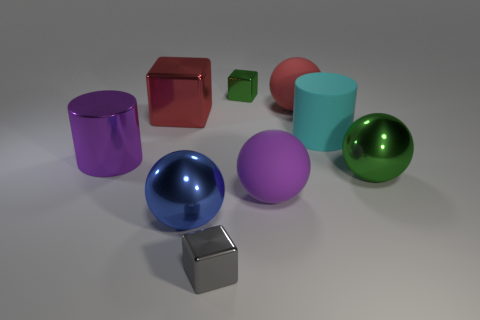Subtract all green cubes. How many cubes are left? 2 Subtract all gray cubes. How many cubes are left? 2 Subtract all cylinders. How many objects are left? 7 Add 1 large red objects. How many objects exist? 10 Subtract all gray cubes. How many purple cylinders are left? 1 Subtract all large red shiny objects. Subtract all large green objects. How many objects are left? 7 Add 4 large shiny cylinders. How many large shiny cylinders are left? 5 Add 8 big green metallic spheres. How many big green metallic spheres exist? 9 Subtract 1 green blocks. How many objects are left? 8 Subtract 1 blocks. How many blocks are left? 2 